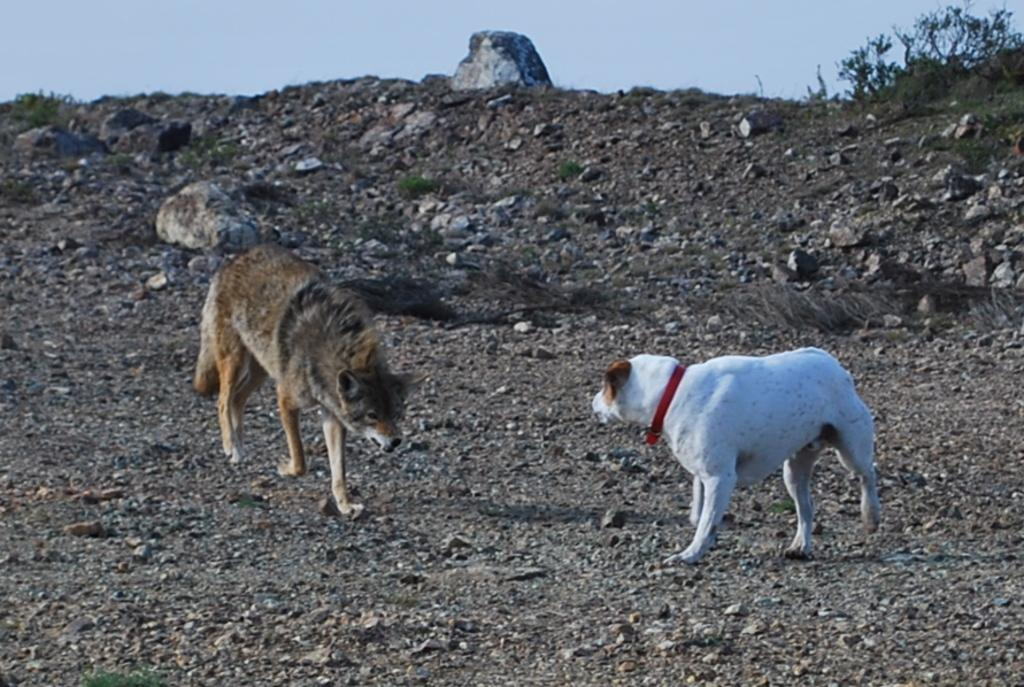What animals are in the center of the image? There are two dogs in the center of the image. What type of terrain is visible at the bottom of the image? There is grass and sand at the bottom of the image. What part of the natural environment is visible in the image? The sky is visible at the top of the image. What type of knot is being tied by the dogs in the image? There are no knots or any indication of tying in the image; it features two dogs in the center. Can you provide an example of a dog breed that is present in the image? The image does not provide enough detail to identify the breed of the dogs, so it is not possible to provide an example. 